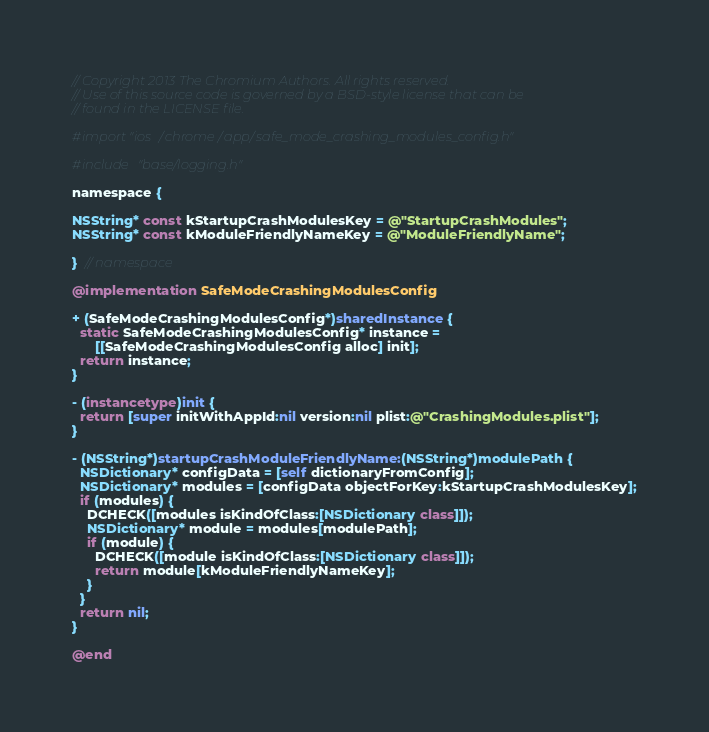<code> <loc_0><loc_0><loc_500><loc_500><_ObjectiveC_>// Copyright 2013 The Chromium Authors. All rights reserved.
// Use of this source code is governed by a BSD-style license that can be
// found in the LICENSE file.

#import "ios/chrome/app/safe_mode_crashing_modules_config.h"

#include "base/logging.h"

namespace {

NSString* const kStartupCrashModulesKey = @"StartupCrashModules";
NSString* const kModuleFriendlyNameKey = @"ModuleFriendlyName";

}  // namespace

@implementation SafeModeCrashingModulesConfig

+ (SafeModeCrashingModulesConfig*)sharedInstance {
  static SafeModeCrashingModulesConfig* instance =
      [[SafeModeCrashingModulesConfig alloc] init];
  return instance;
}

- (instancetype)init {
  return [super initWithAppId:nil version:nil plist:@"CrashingModules.plist"];
}

- (NSString*)startupCrashModuleFriendlyName:(NSString*)modulePath {
  NSDictionary* configData = [self dictionaryFromConfig];
  NSDictionary* modules = [configData objectForKey:kStartupCrashModulesKey];
  if (modules) {
    DCHECK([modules isKindOfClass:[NSDictionary class]]);
    NSDictionary* module = modules[modulePath];
    if (module) {
      DCHECK([module isKindOfClass:[NSDictionary class]]);
      return module[kModuleFriendlyNameKey];
    }
  }
  return nil;
}

@end
</code> 